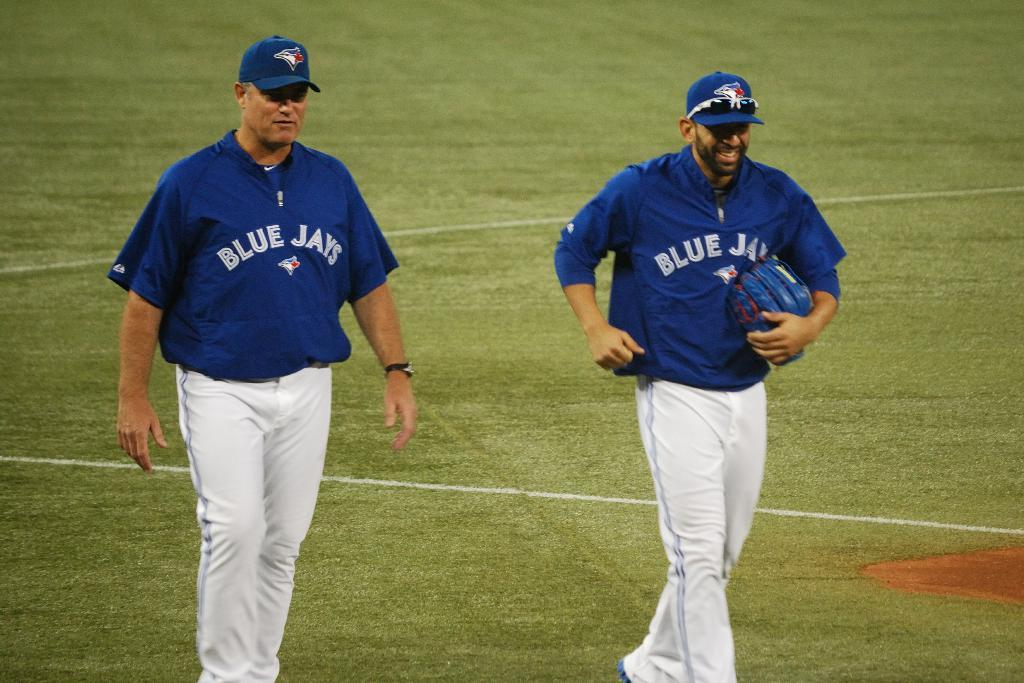<image>
Share a concise interpretation of the image provided. The men are dressed to play baseball for the Blue Jays. 